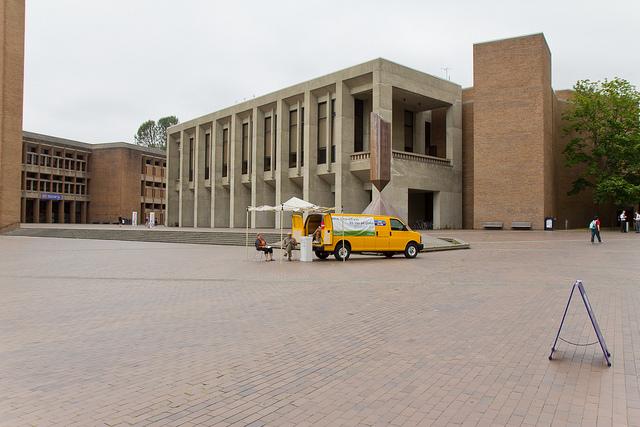Is the square empty?
Short answer required. No. What color is the truck?
Quick response, please. Yellow. How many people are there near the yellow truck?
Write a very short answer. 2. 